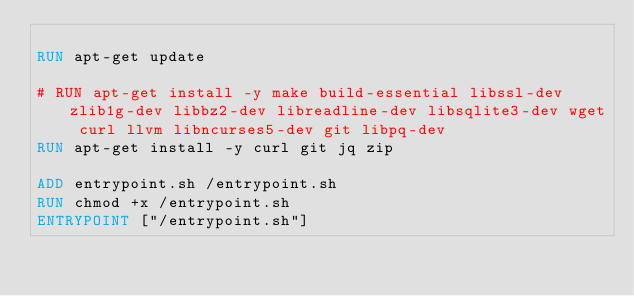<code> <loc_0><loc_0><loc_500><loc_500><_Dockerfile_>
RUN apt-get update

# RUN apt-get install -y make build-essential libssl-dev zlib1g-dev libbz2-dev libreadline-dev libsqlite3-dev wget curl llvm libncurses5-dev git libpq-dev
RUN apt-get install -y curl git jq zip

ADD entrypoint.sh /entrypoint.sh
RUN chmod +x /entrypoint.sh
ENTRYPOINT ["/entrypoint.sh"]
</code> 